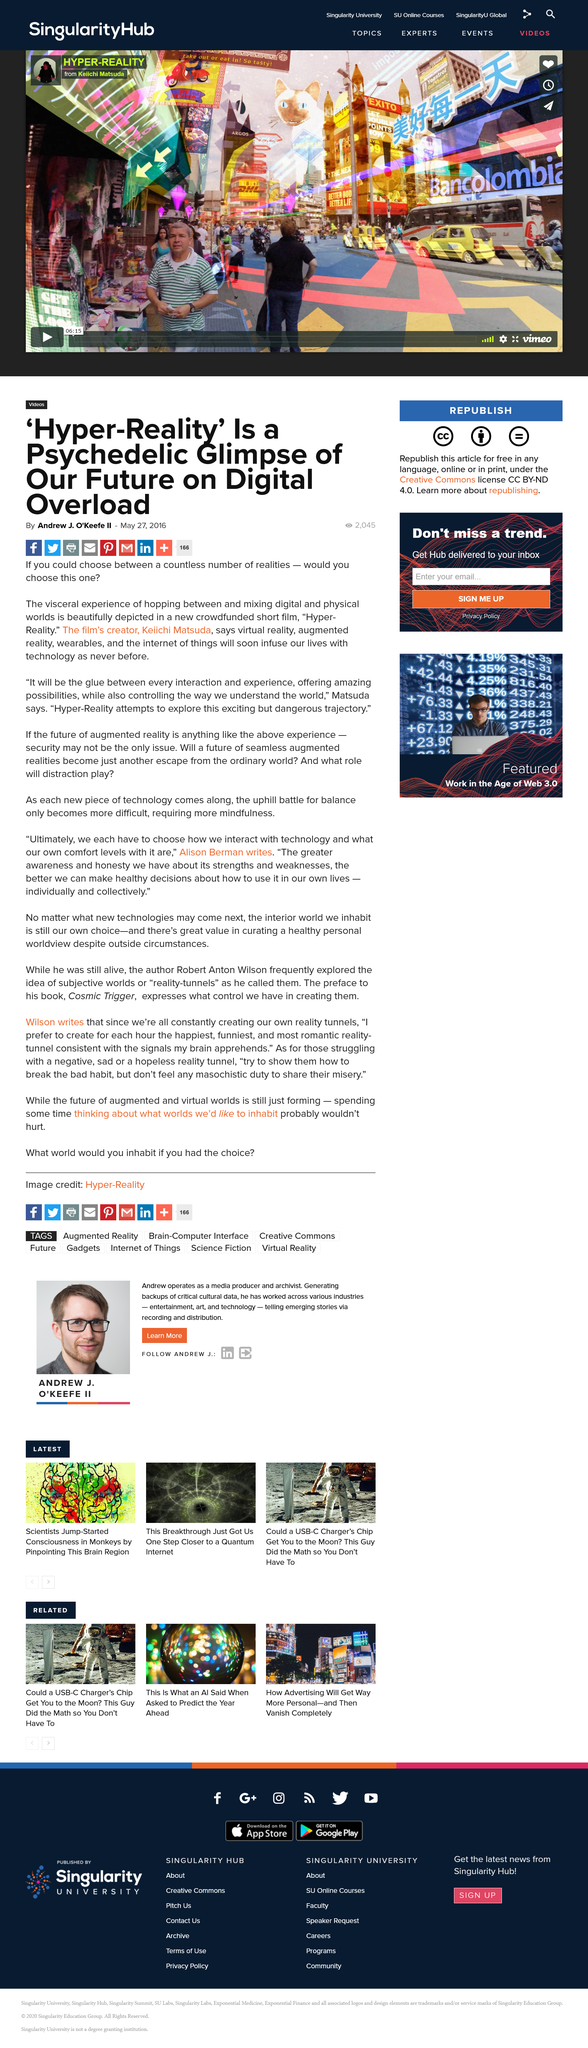Indicate a few pertinent items in this graphic. The title of this article is 'Hyper-Reality: A Psychedelic Glimpse into Our Future on Digital Overload'. This article is about Hyper-Reality, which is a concept that refers to the blurring of the boundary between the physical and digital worlds. This article was published on May 27, 2016. 